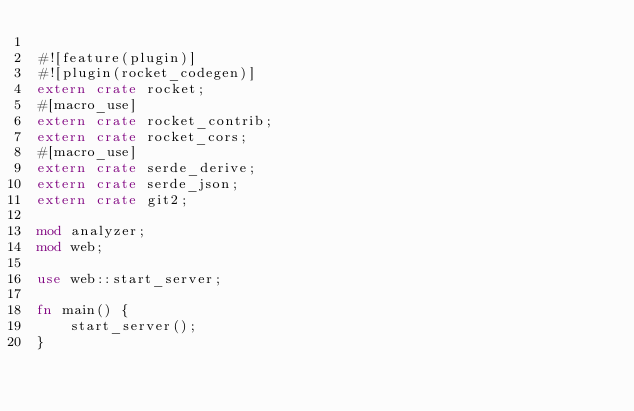<code> <loc_0><loc_0><loc_500><loc_500><_Rust_>
#![feature(plugin)]
#![plugin(rocket_codegen)]
extern crate rocket;
#[macro_use]
extern crate rocket_contrib;
extern crate rocket_cors;
#[macro_use]
extern crate serde_derive;
extern crate serde_json;
extern crate git2;

mod analyzer;
mod web;

use web::start_server;

fn main() {
    start_server();
}

</code> 